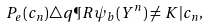<formula> <loc_0><loc_0><loc_500><loc_500>P _ { \, e } ( c _ { n } ) \triangle q \P R { \psi _ { b } ( Y ^ { n } ) \neq K | c _ { n } } ,</formula> 